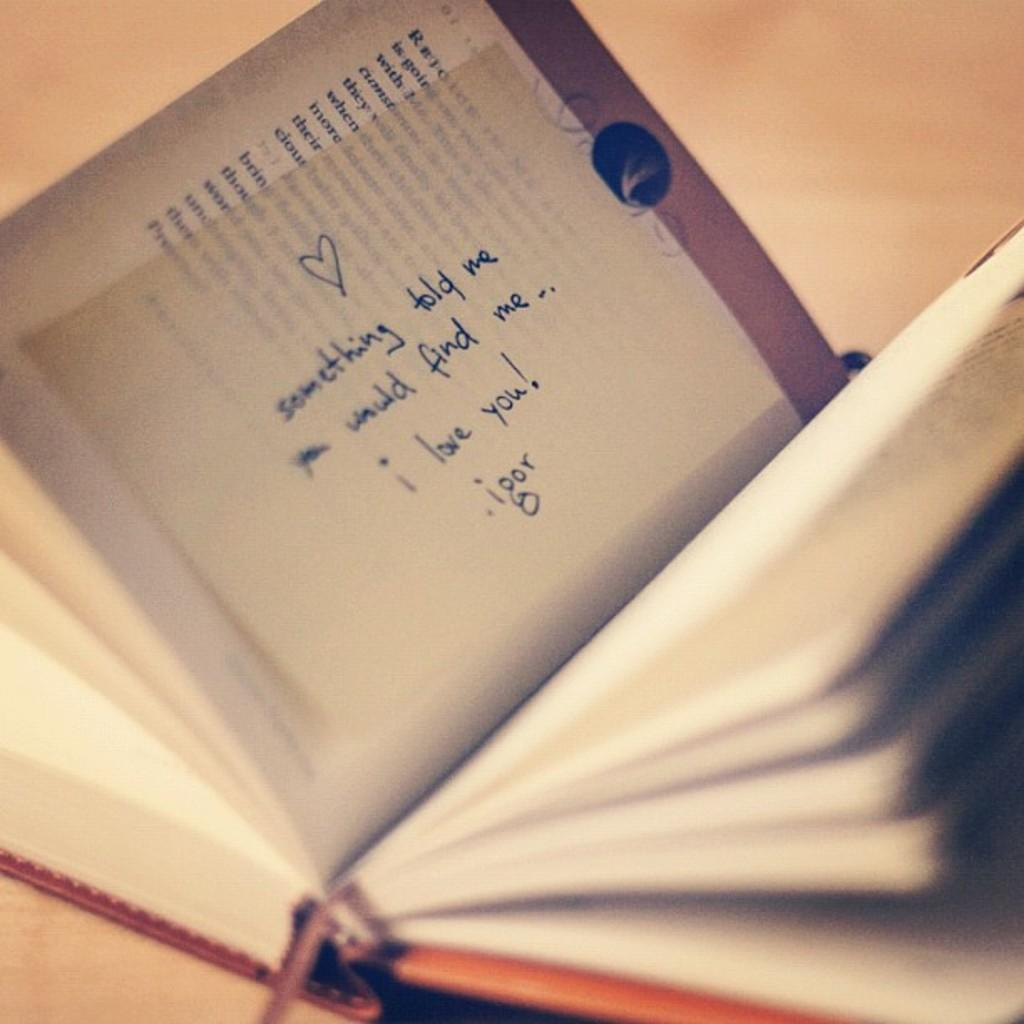What is present in the image? There is a book in the image. Can you describe the book further? There are sticky notes on a page of the book. What type of beast can be seen bursting through the wall in the image? There is no beast or wall present in the image; it only features a book with sticky notes on a page. 